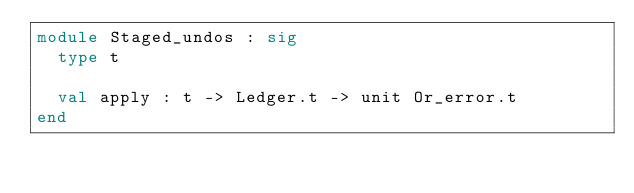<code> <loc_0><loc_0><loc_500><loc_500><_OCaml_>module Staged_undos : sig
  type t

  val apply : t -> Ledger.t -> unit Or_error.t
end
</code> 